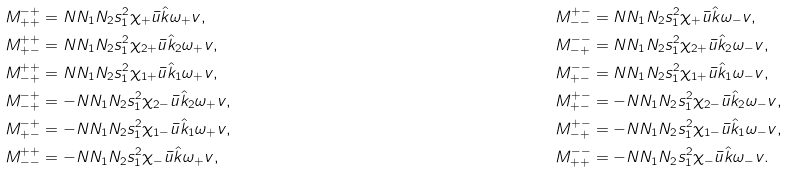Convert formula to latex. <formula><loc_0><loc_0><loc_500><loc_500>& M _ { + + } ^ { - + } = N N _ { 1 } N _ { 2 } s _ { 1 } ^ { 2 } \chi _ { + } \bar { u } \hat { k } \omega _ { + } v , \quad & & M _ { - - } ^ { + - } = N N _ { 1 } N _ { 2 } s _ { 1 } ^ { 2 } \chi _ { + } \bar { u } \hat { k } \omega _ { - } v , \\ & M _ { + - } ^ { + + } = N N _ { 1 } N _ { 2 } s _ { 1 } ^ { 2 } \chi _ { 2 + } \bar { u } \hat { k } _ { 2 } \omega _ { + } v , \quad & & M _ { - + } ^ { - - } = N N _ { 1 } N _ { 2 } s _ { 1 } ^ { 2 } \chi _ { 2 + } \bar { u } \hat { k } _ { 2 } \omega _ { - } v , \\ & M _ { - + } ^ { + + } = N N _ { 1 } N _ { 2 } s _ { 1 } ^ { 2 } \chi _ { 1 + } \bar { u } \hat { k } _ { 1 } \omega _ { + } v , \quad & & M _ { + - } ^ { - - } = N N _ { 1 } N _ { 2 } s _ { 1 } ^ { 2 } \chi _ { 1 + } \bar { u } \hat { k } _ { 1 } \omega _ { - } v , \\ & M _ { - + } ^ { - + } = - N N _ { 1 } N _ { 2 } s _ { 1 } ^ { 2 } \chi _ { 2 - } \bar { u } \hat { k } _ { 2 } \omega _ { + } v , \quad & & M _ { + - } ^ { + - } = - N N _ { 1 } N _ { 2 } s _ { 1 } ^ { 2 } \chi _ { 2 - } \bar { u } \hat { k } _ { 2 } \omega _ { - } v , \\ & M _ { + - } ^ { - + } = - N N _ { 1 } N _ { 2 } s _ { 1 } ^ { 2 } \chi _ { 1 - } \bar { u } \hat { k } _ { 1 } \omega _ { + } v , \quad & & M _ { - + } ^ { + - } = - N N _ { 1 } N _ { 2 } s _ { 1 } ^ { 2 } \chi _ { 1 - } \bar { u } \hat { k } _ { 1 } \omega _ { - } v , \\ & M _ { - - } ^ { + + } = - N N _ { 1 } N _ { 2 } s _ { 1 } ^ { 2 } \chi _ { - } \bar { u } \hat { k } \omega _ { + } v , \quad & & M _ { + + } ^ { - - } = - N N _ { 1 } N _ { 2 } s _ { 1 } ^ { 2 } \chi _ { - } \bar { u } \hat { k } \omega _ { - } v .</formula> 